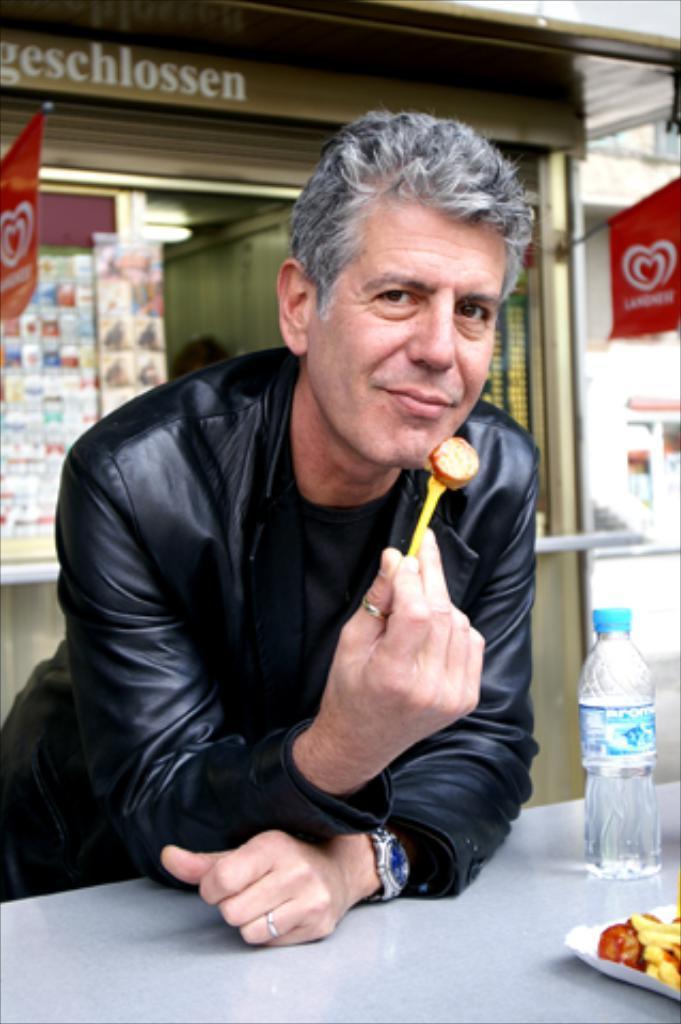Please provide a concise description of this image. The image is clicked outside the shop. In this image, there is a man holding food in his hand. He is wearing a black colored jacket. To the right, there is bottle and food on the table. In the background, there is a shop. 